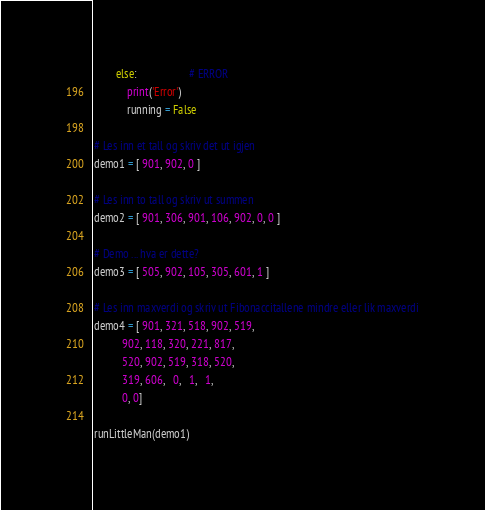<code> <loc_0><loc_0><loc_500><loc_500><_Python_>        else:                   # ERROR
            print('Error')
            running = False

# Les inn et tall og skriv det ut igjen
demo1 = [ 901, 902, 0 ]

# Les inn to tall og skriv ut summen
demo2 = [ 901, 306, 901, 106, 902, 0, 0 ]

# Demo ... hva er dette?
demo3 = [ 505, 902, 105, 305, 601, 1 ]

# Les inn maxverdi og skriv ut Fibonaccitallene mindre eller lik maxverdi
demo4 = [ 901, 321, 518, 902, 519,
          902, 118, 320, 221, 817,
          520, 902, 519, 318, 520,
          319, 606,   0,   1,   1,
          0, 0]

runLittleMan(demo1)</code> 